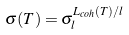Convert formula to latex. <formula><loc_0><loc_0><loc_500><loc_500>\sigma ( T ) = \sigma _ { l } ^ { L _ { c o h } ( T ) / l }</formula> 